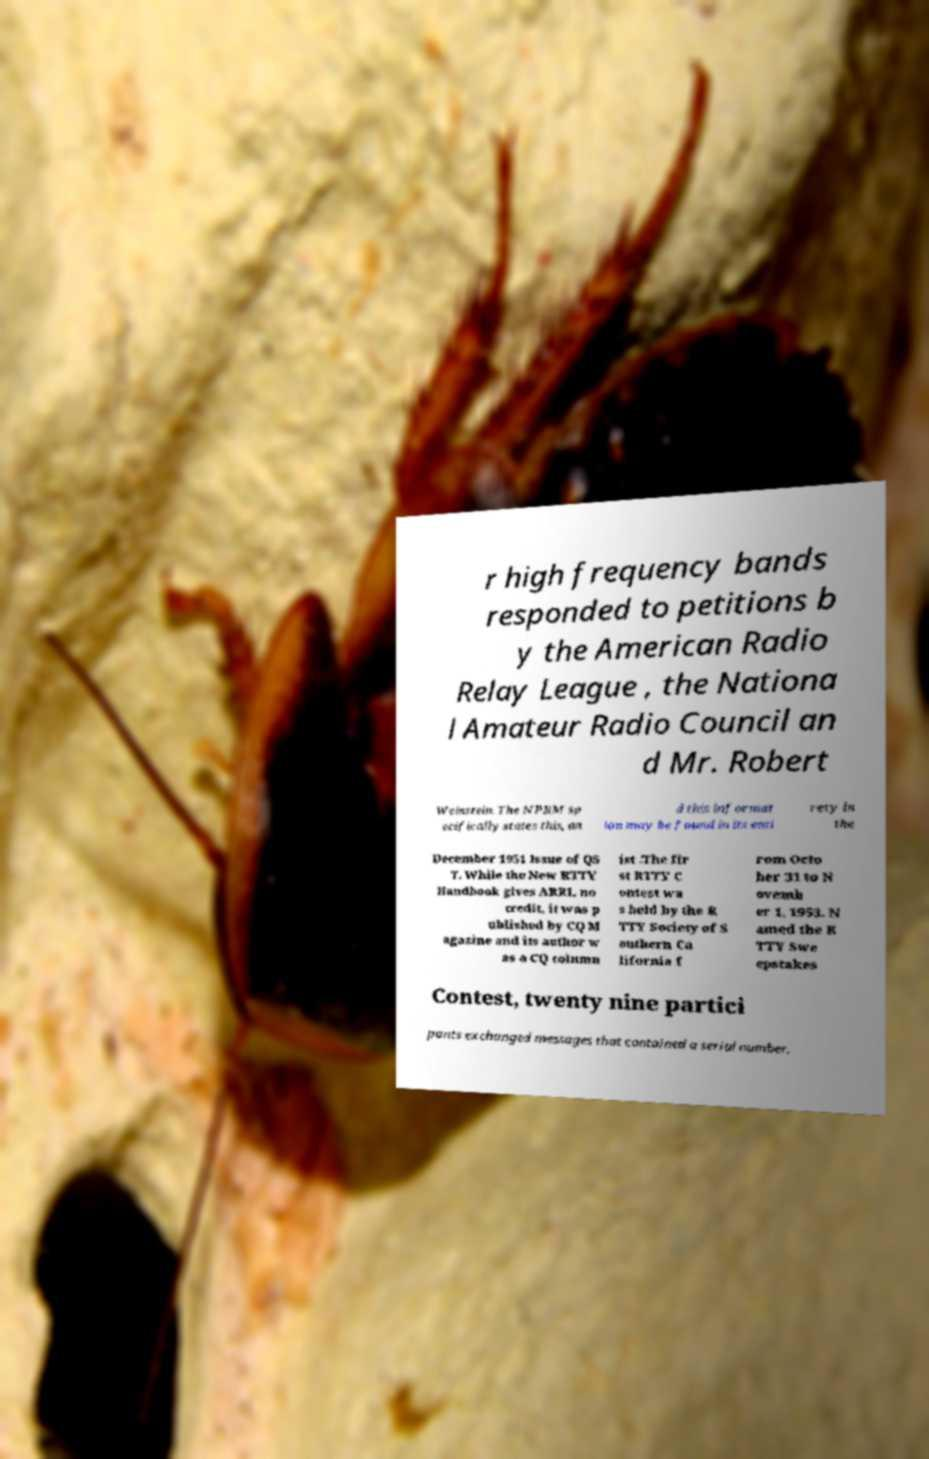Could you assist in decoding the text presented in this image and type it out clearly? r high frequency bands responded to petitions b y the American Radio Relay League , the Nationa l Amateur Radio Council an d Mr. Robert Weinstein. The NPRM sp ecifically states this, an d this informat ion may be found in its enti rety in the December 1951 Issue of QS T. While the New RTTY Handbook gives ARRL no credit, it was p ublished by CQ M agazine and its author w as a CQ column ist .The fir st RTTY C ontest wa s held by the R TTY Society of S outhern Ca lifornia f rom Octo ber 31 to N ovemb er 1, 1953. N amed the R TTY Swe epstakes Contest, twenty nine partici pants exchanged messages that contained a serial number, 